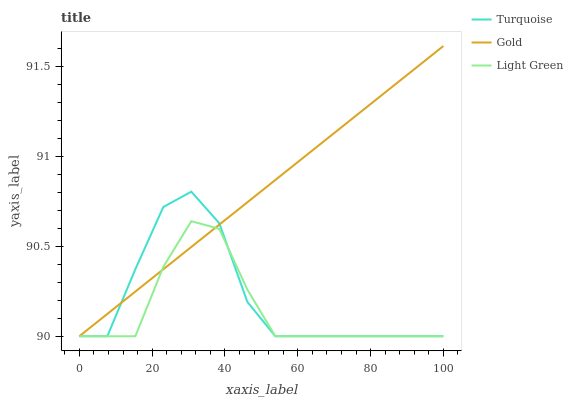Does Light Green have the minimum area under the curve?
Answer yes or no. Yes. Does Gold have the maximum area under the curve?
Answer yes or no. Yes. Does Gold have the minimum area under the curve?
Answer yes or no. No. Does Light Green have the maximum area under the curve?
Answer yes or no. No. Is Gold the smoothest?
Answer yes or no. Yes. Is Turquoise the roughest?
Answer yes or no. Yes. Is Light Green the smoothest?
Answer yes or no. No. Is Light Green the roughest?
Answer yes or no. No. Does Gold have the highest value?
Answer yes or no. Yes. Does Light Green have the highest value?
Answer yes or no. No. Does Light Green intersect Gold?
Answer yes or no. Yes. Is Light Green less than Gold?
Answer yes or no. No. Is Light Green greater than Gold?
Answer yes or no. No. 